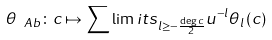<formula> <loc_0><loc_0><loc_500><loc_500>\theta _ { \ A b } \colon c \mapsto \sum \lim i t s _ { l \geq - \frac { \deg c } { 2 } } u ^ { - l } \theta _ { l } \left ( c \right )</formula> 